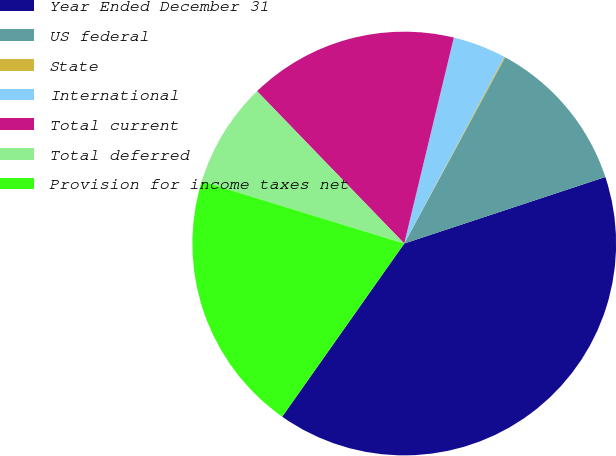Convert chart to OTSL. <chart><loc_0><loc_0><loc_500><loc_500><pie_chart><fcel>Year Ended December 31<fcel>US federal<fcel>State<fcel>International<fcel>Total current<fcel>Total deferred<fcel>Provision for income taxes net<nl><fcel>39.86%<fcel>12.01%<fcel>0.08%<fcel>4.06%<fcel>15.99%<fcel>8.03%<fcel>19.97%<nl></chart> 